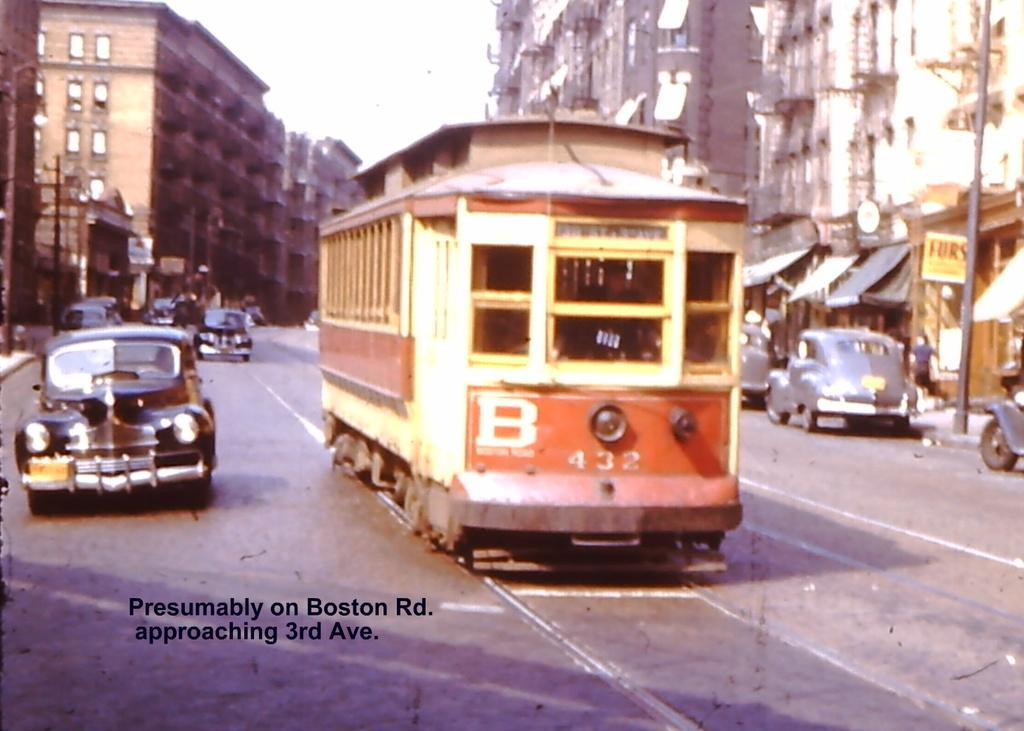<image>
Write a terse but informative summary of the picture. Both a car and a B line trolley travelling on Boston Road. 